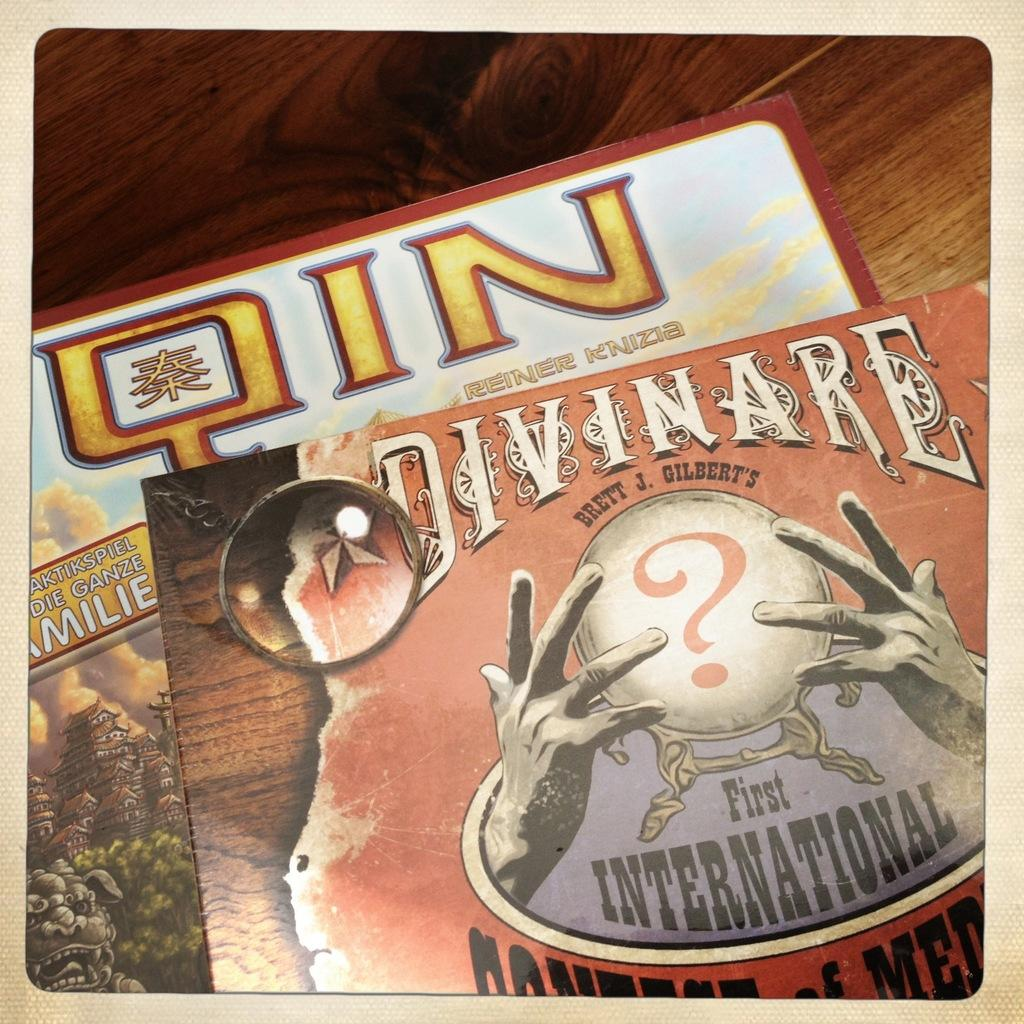<image>
Describe the image concisely. two different books stacked on each other called qin and divinare. 